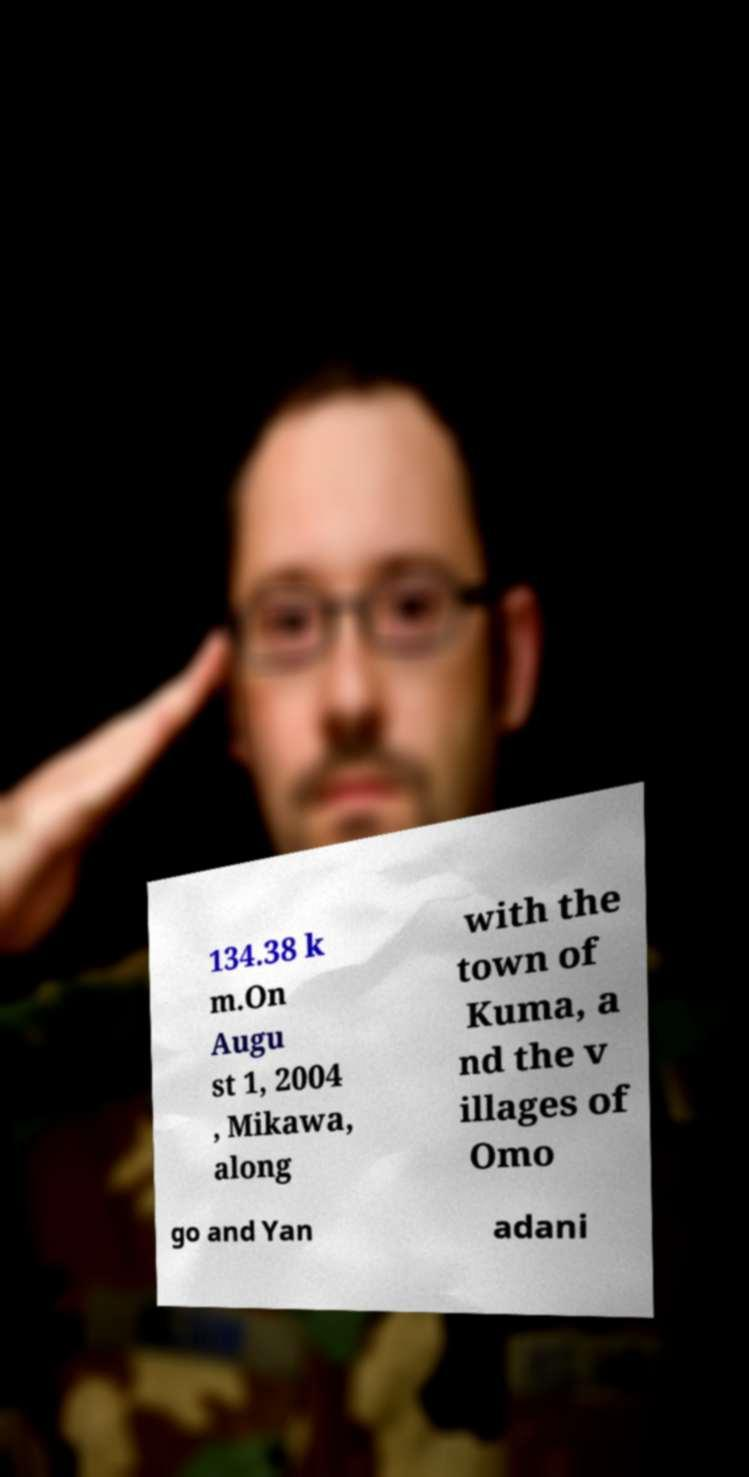Can you accurately transcribe the text from the provided image for me? 134.38 k m.On Augu st 1, 2004 , Mikawa, along with the town of Kuma, a nd the v illages of Omo go and Yan adani 